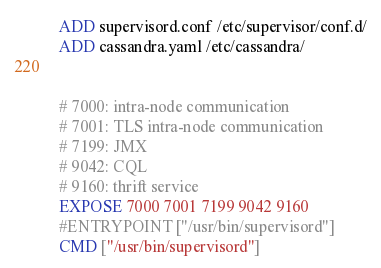<code> <loc_0><loc_0><loc_500><loc_500><_Dockerfile_>
ADD supervisord.conf /etc/supervisor/conf.d/
ADD cassandra.yaml /etc/cassandra/


# 7000: intra-node communication
# 7001: TLS intra-node communication
# 7199: JMX
# 9042: CQL
# 9160: thrift service
EXPOSE 7000 7001 7199 9042 9160
#ENTRYPOINT ["/usr/bin/supervisord"]
CMD ["/usr/bin/supervisord"]
</code> 